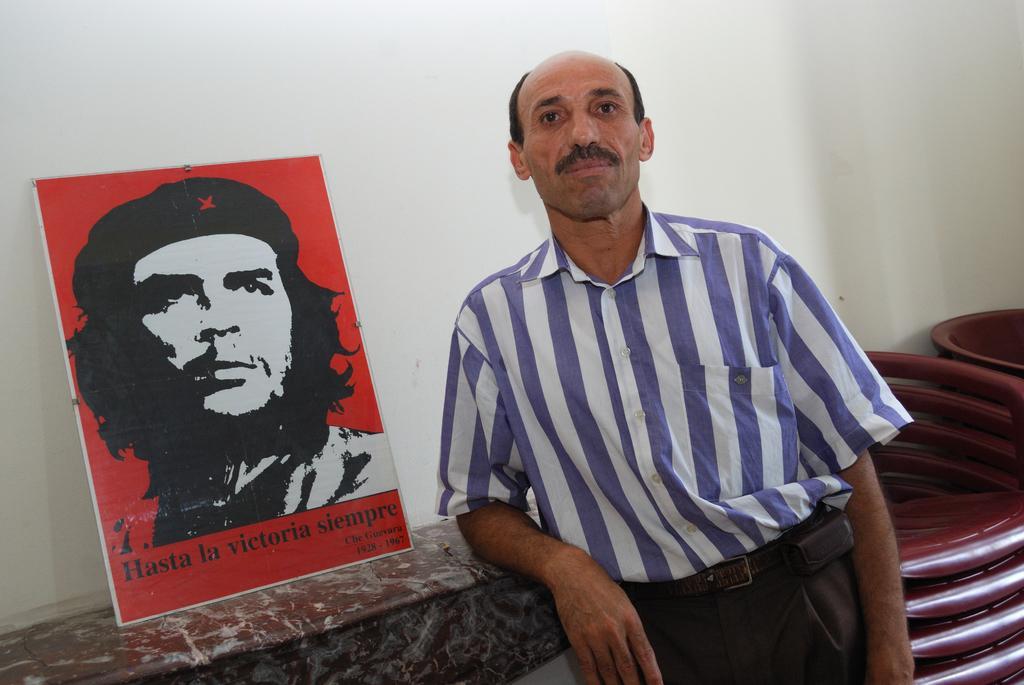Describe this image in one or two sentences. In the foreground of the image we can see a person wearing dress is standing. To the right side of the image ,we can see group of chairs. On the left side of the image ,we can see a photo frame placed on the rack. 